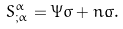<formula> <loc_0><loc_0><loc_500><loc_500>S ^ { \alpha } _ { ; \alpha } = \Psi \sigma + n \dot { \sigma } .</formula> 